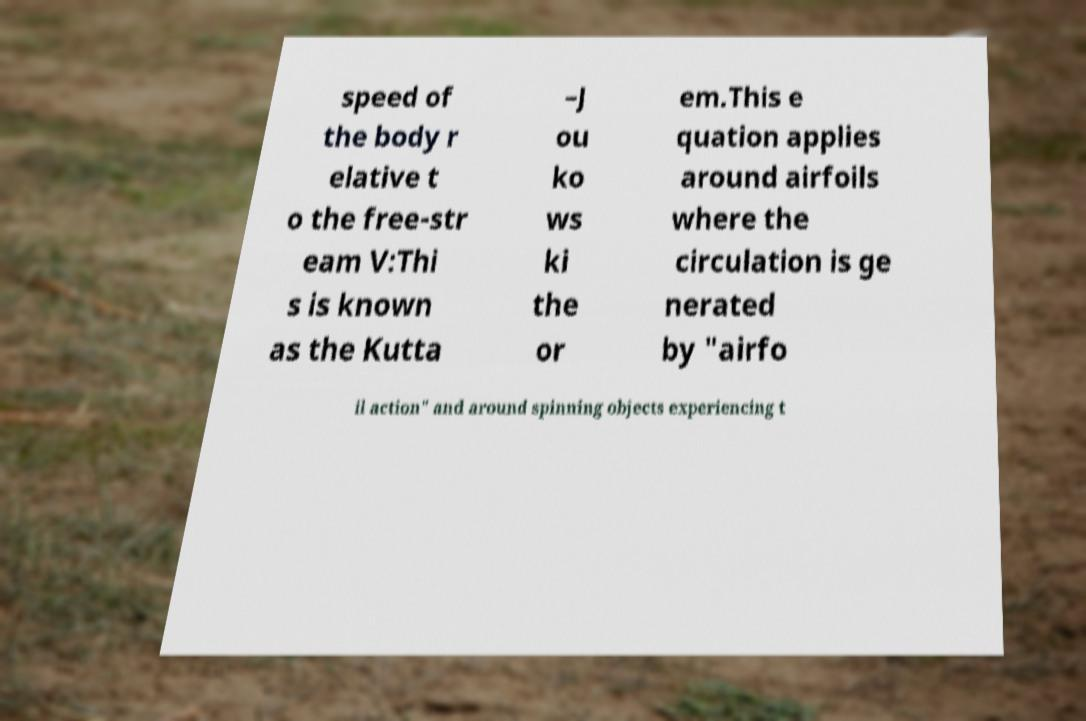Can you accurately transcribe the text from the provided image for me? speed of the body r elative t o the free-str eam V:Thi s is known as the Kutta –J ou ko ws ki the or em.This e quation applies around airfoils where the circulation is ge nerated by "airfo il action" and around spinning objects experiencing t 